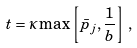Convert formula to latex. <formula><loc_0><loc_0><loc_500><loc_500>t = \kappa \max \left [ { \bar { p } } _ { j } , \frac { 1 } { b } \right ] \, ,</formula> 